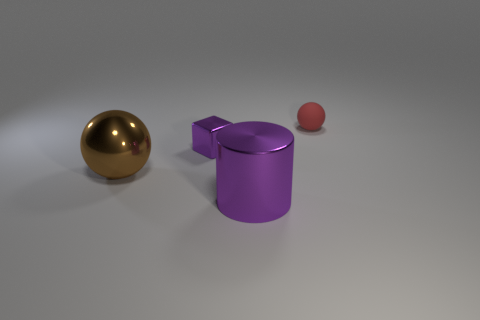Add 2 big purple shiny things. How many objects exist? 6 Subtract all red spheres. How many spheres are left? 1 Subtract 0 brown cubes. How many objects are left? 4 Subtract all cylinders. How many objects are left? 3 Subtract 1 cubes. How many cubes are left? 0 Subtract all blue spheres. Subtract all purple cylinders. How many spheres are left? 2 Subtract all large metal cylinders. Subtract all brown shiny objects. How many objects are left? 2 Add 4 cubes. How many cubes are left? 5 Add 4 tiny shiny objects. How many tiny shiny objects exist? 5 